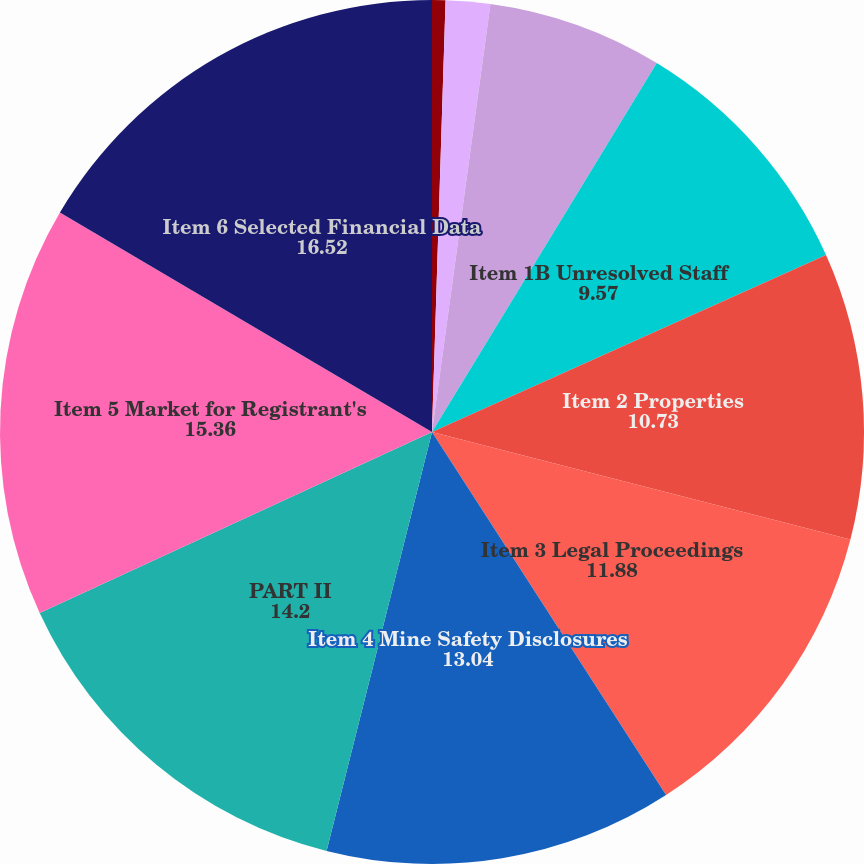Convert chart. <chart><loc_0><loc_0><loc_500><loc_500><pie_chart><fcel>PART I<fcel>Item 1 Business<fcel>Item 1A Risk Factors<fcel>Item 1B Unresolved Staff<fcel>Item 2 Properties<fcel>Item 3 Legal Proceedings<fcel>Item 4 Mine Safety Disclosures<fcel>PART II<fcel>Item 5 Market for Registrant's<fcel>Item 6 Selected Financial Data<nl><fcel>0.5%<fcel>1.66%<fcel>6.55%<fcel>9.57%<fcel>10.73%<fcel>11.88%<fcel>13.04%<fcel>14.2%<fcel>15.36%<fcel>16.52%<nl></chart> 